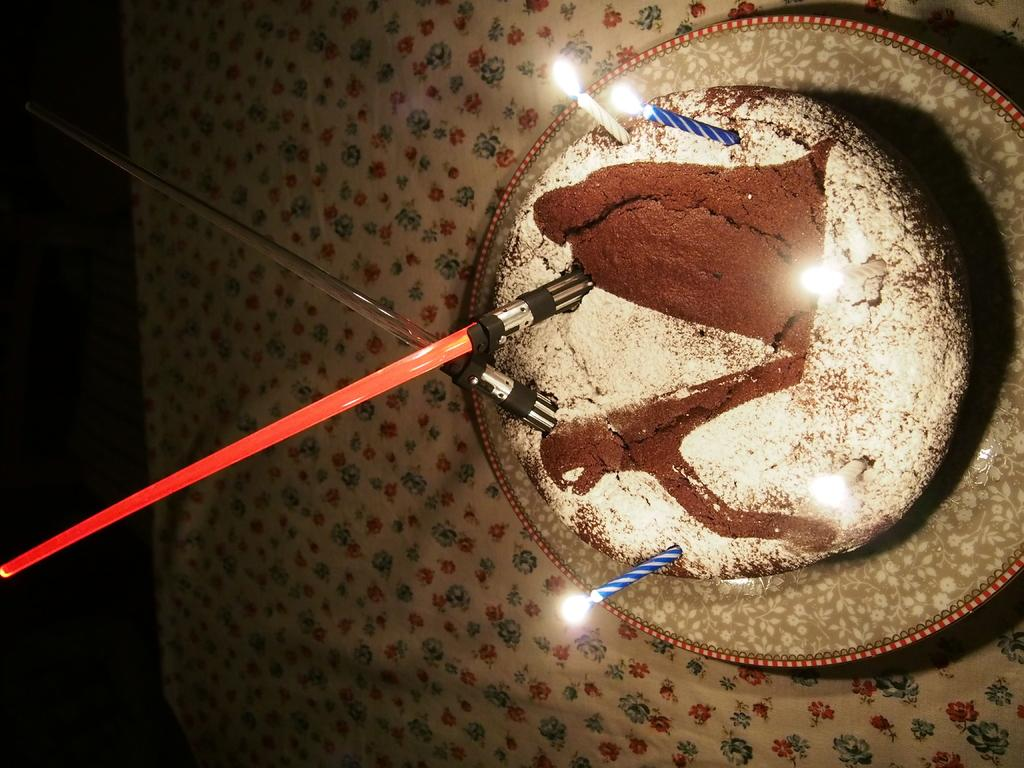What is the main subject of the image? The main subject of the image is a cake with candles. How is the cake positioned in the image? The cake is on a plate in the image. What is the surface beneath the plate? There is a table with a cloth on it in the image. What can be seen on top of the cake? There are objects on the cake in the image. What type of basketball game is taking place in the alley behind the table? There is no basketball game or alley present in the image; it only features a cake with candles on a table with a cloth. 